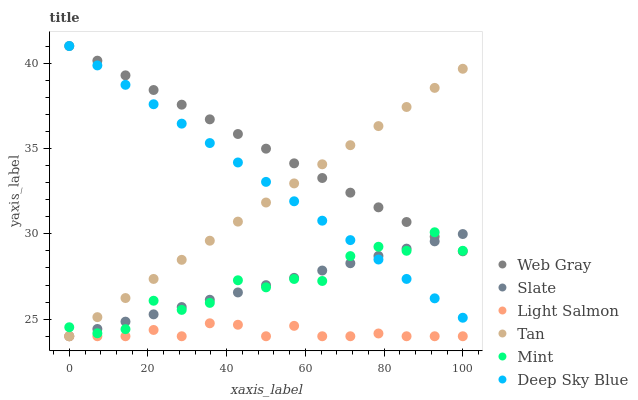Does Light Salmon have the minimum area under the curve?
Answer yes or no. Yes. Does Web Gray have the maximum area under the curve?
Answer yes or no. Yes. Does Slate have the minimum area under the curve?
Answer yes or no. No. Does Slate have the maximum area under the curve?
Answer yes or no. No. Is Slate the smoothest?
Answer yes or no. Yes. Is Mint the roughest?
Answer yes or no. Yes. Is Web Gray the smoothest?
Answer yes or no. No. Is Web Gray the roughest?
Answer yes or no. No. Does Light Salmon have the lowest value?
Answer yes or no. Yes. Does Web Gray have the lowest value?
Answer yes or no. No. Does Deep Sky Blue have the highest value?
Answer yes or no. Yes. Does Slate have the highest value?
Answer yes or no. No. Is Light Salmon less than Mint?
Answer yes or no. Yes. Is Deep Sky Blue greater than Light Salmon?
Answer yes or no. Yes. Does Tan intersect Mint?
Answer yes or no. Yes. Is Tan less than Mint?
Answer yes or no. No. Is Tan greater than Mint?
Answer yes or no. No. Does Light Salmon intersect Mint?
Answer yes or no. No. 